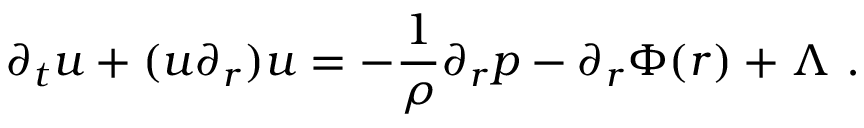Convert formula to latex. <formula><loc_0><loc_0><loc_500><loc_500>\partial _ { t } u + ( u \partial _ { r } ) u = - \frac { 1 } { \rho } \partial _ { r } p - \partial _ { r } \Phi ( r ) + \Lambda \ .</formula> 